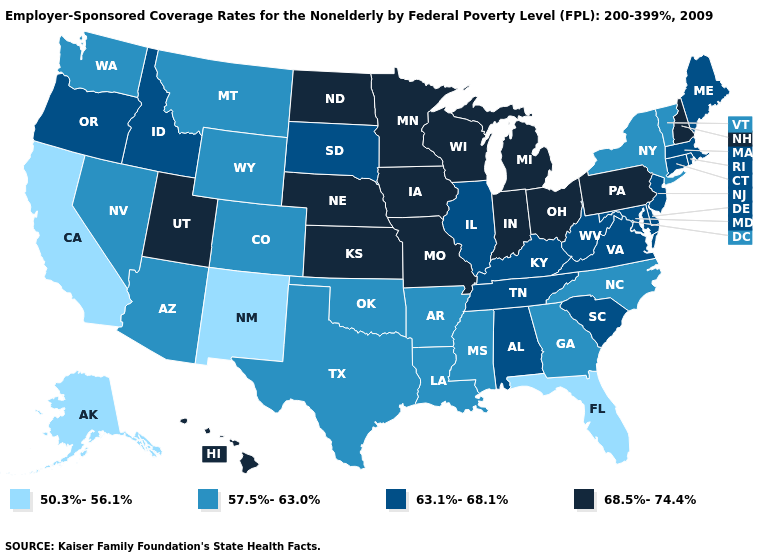Does Delaware have a higher value than Colorado?
Write a very short answer. Yes. Name the states that have a value in the range 68.5%-74.4%?
Keep it brief. Hawaii, Indiana, Iowa, Kansas, Michigan, Minnesota, Missouri, Nebraska, New Hampshire, North Dakota, Ohio, Pennsylvania, Utah, Wisconsin. Does Alabama have the highest value in the South?
Concise answer only. Yes. What is the highest value in states that border Ohio?
Write a very short answer. 68.5%-74.4%. What is the highest value in the Northeast ?
Give a very brief answer. 68.5%-74.4%. What is the value of North Carolina?
Give a very brief answer. 57.5%-63.0%. Name the states that have a value in the range 63.1%-68.1%?
Be succinct. Alabama, Connecticut, Delaware, Idaho, Illinois, Kentucky, Maine, Maryland, Massachusetts, New Jersey, Oregon, Rhode Island, South Carolina, South Dakota, Tennessee, Virginia, West Virginia. What is the highest value in states that border Missouri?
Quick response, please. 68.5%-74.4%. What is the value of Ohio?
Answer briefly. 68.5%-74.4%. Does Louisiana have a higher value than North Carolina?
Give a very brief answer. No. What is the highest value in the South ?
Give a very brief answer. 63.1%-68.1%. What is the highest value in the USA?
Write a very short answer. 68.5%-74.4%. What is the value of Connecticut?
Keep it brief. 63.1%-68.1%. Name the states that have a value in the range 63.1%-68.1%?
Give a very brief answer. Alabama, Connecticut, Delaware, Idaho, Illinois, Kentucky, Maine, Maryland, Massachusetts, New Jersey, Oregon, Rhode Island, South Carolina, South Dakota, Tennessee, Virginia, West Virginia. What is the lowest value in the USA?
Keep it brief. 50.3%-56.1%. 